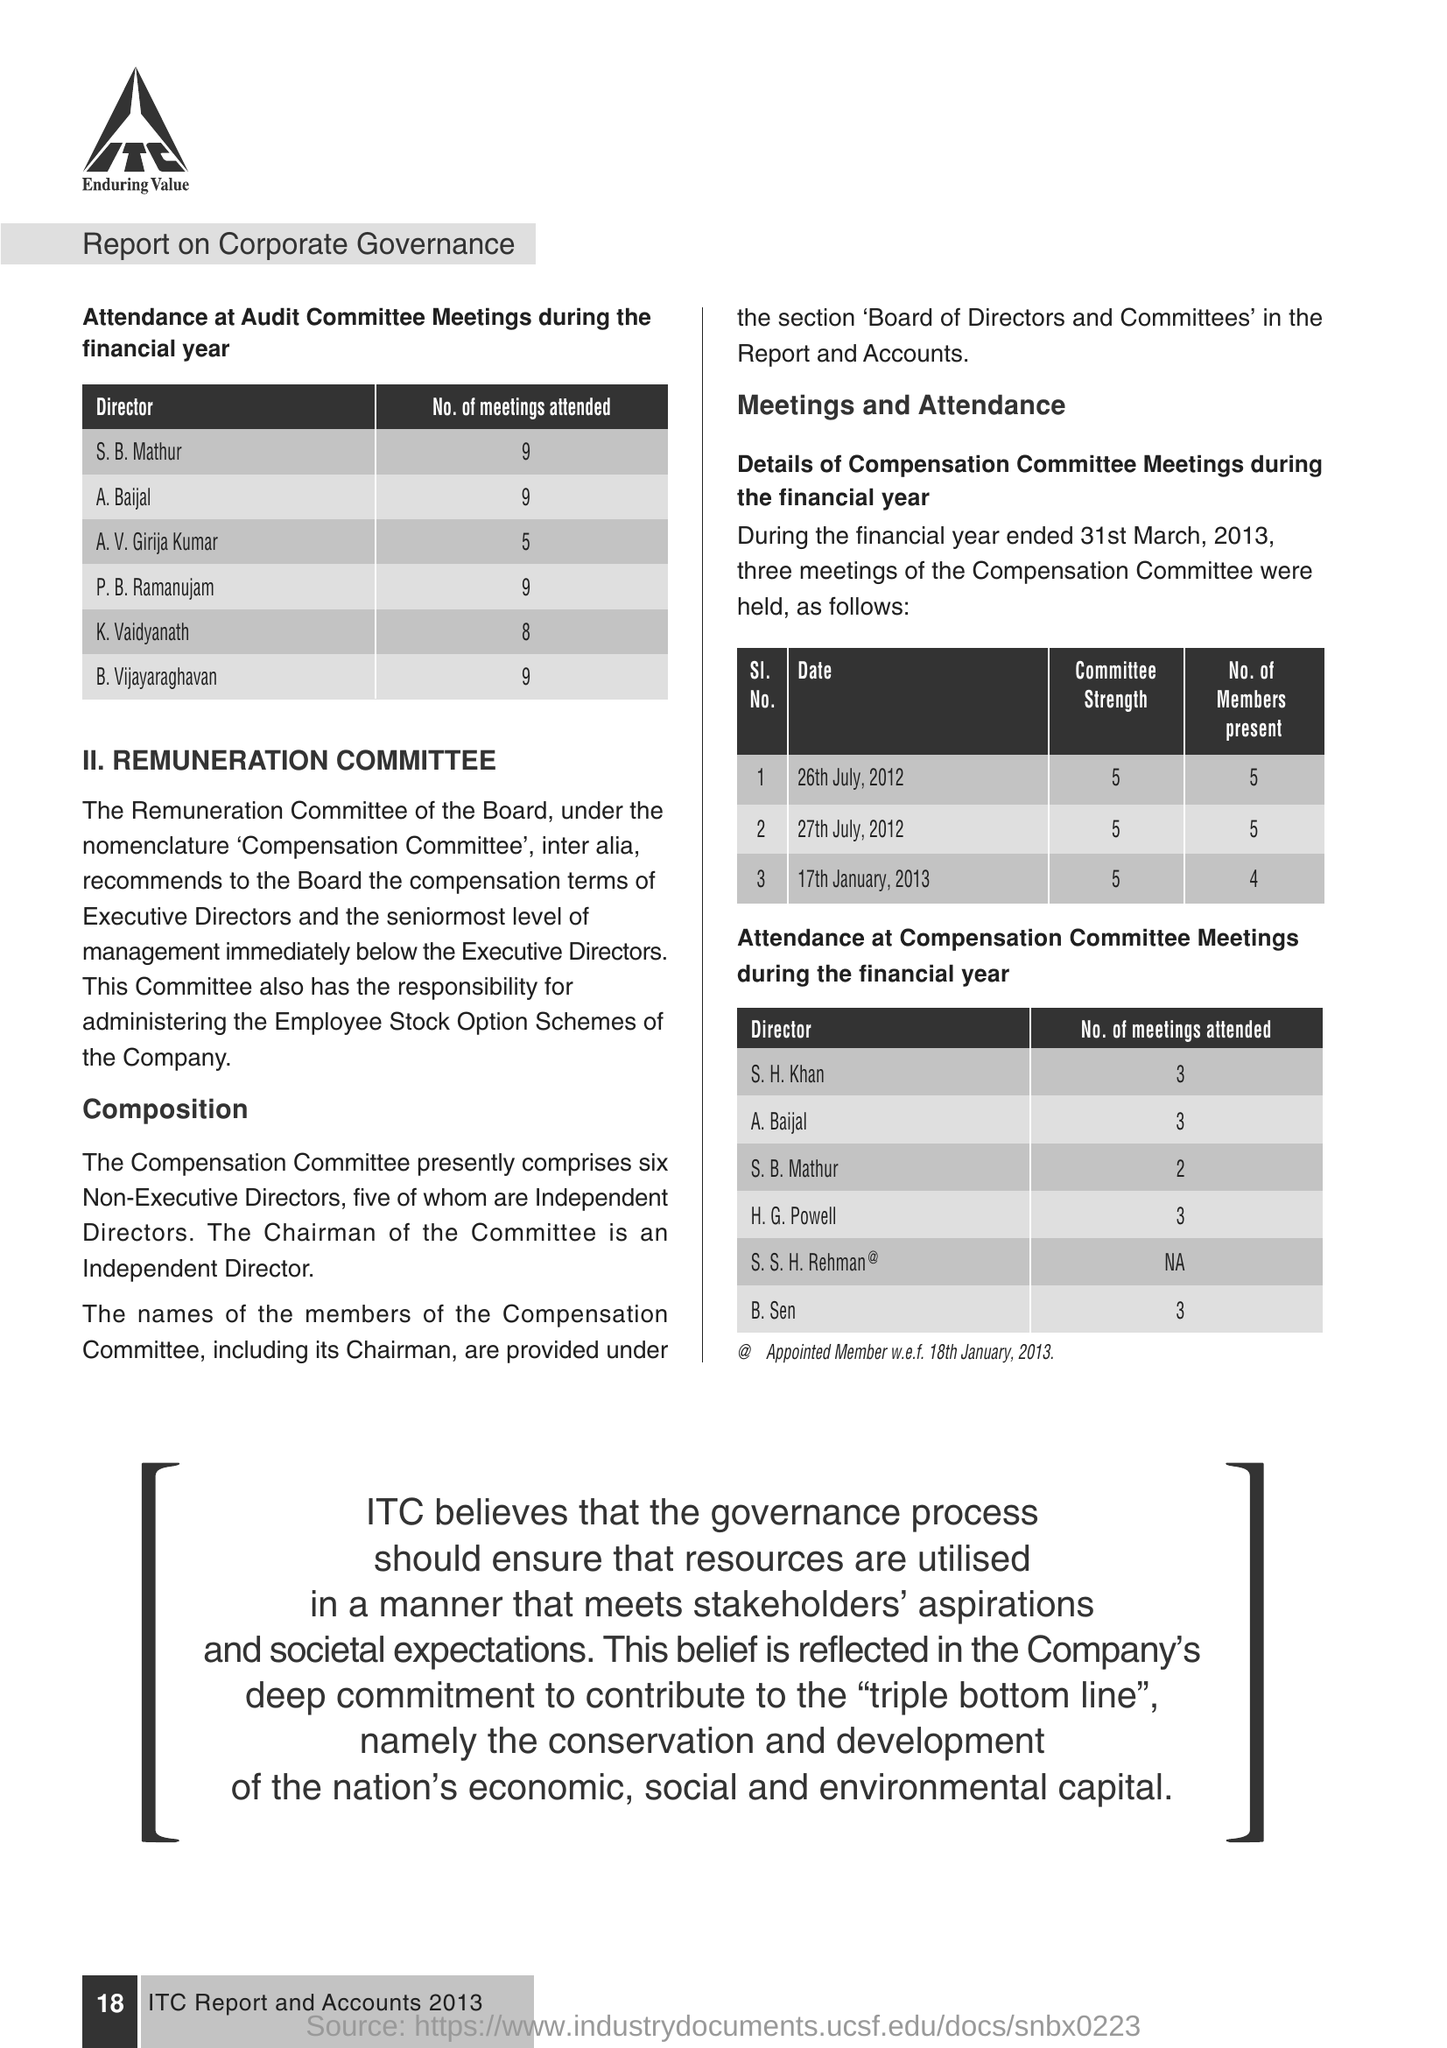How many meetings have K. Vaidyanath attended at the audit committee meetings during the financial year ?
Give a very brief answer. 8. How many Compensation committee meetings were held during the financial year?
Your response must be concise. 3. How many compensation committee meetings did the director S.B. Mathur attend ?
Your answer should be very brief. 2. 